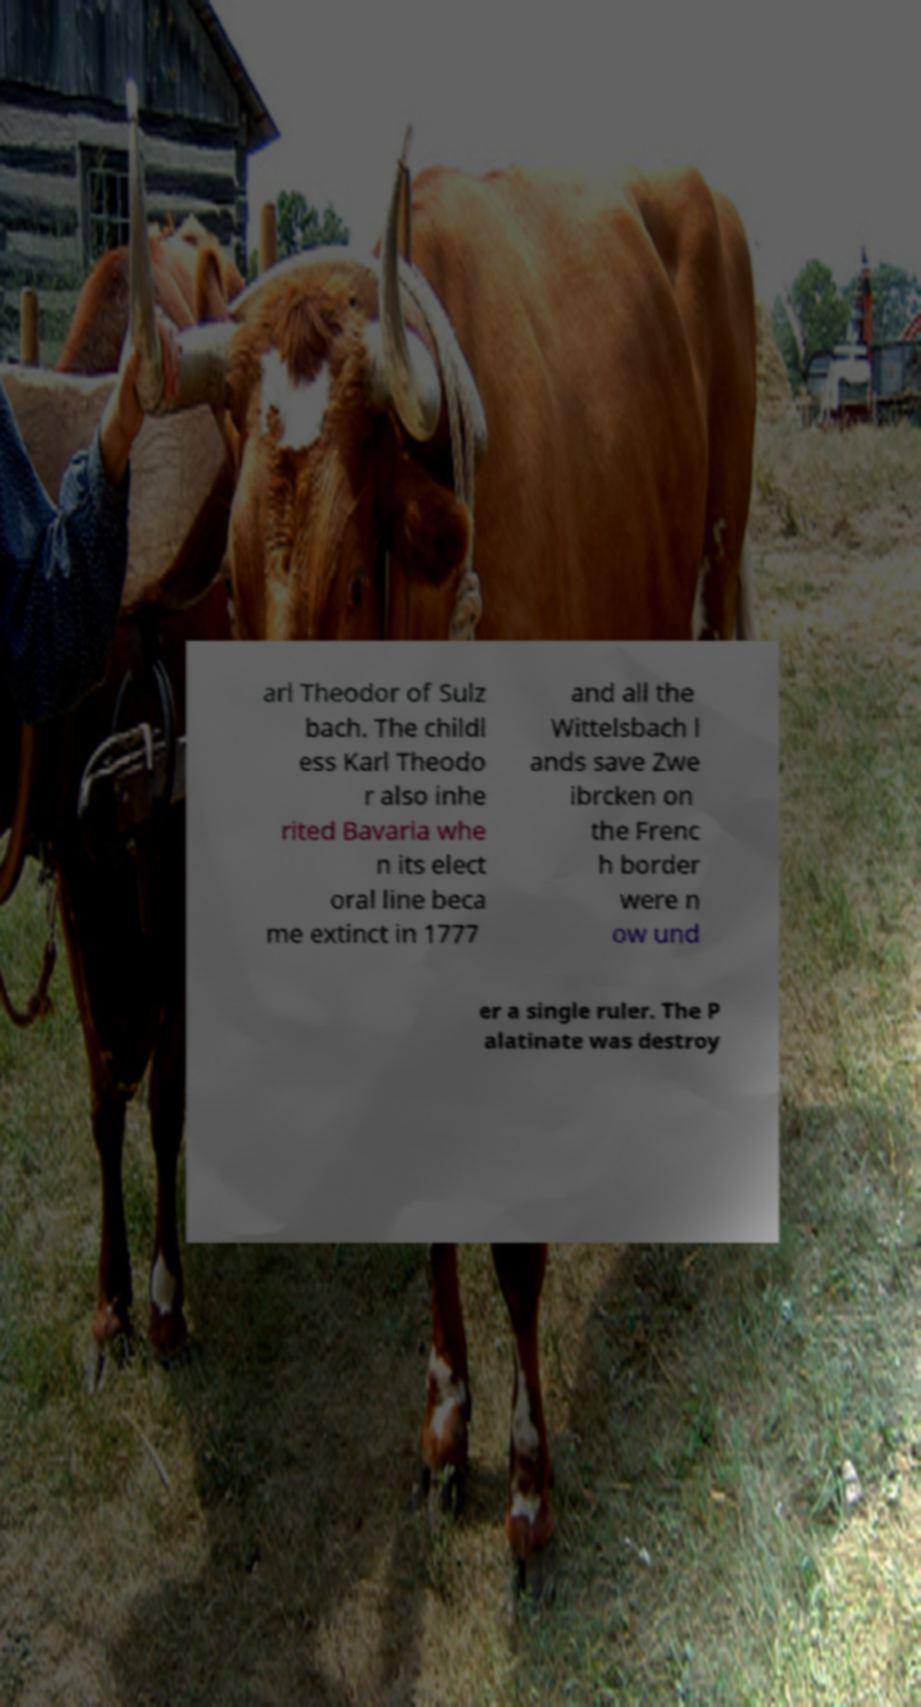Can you read and provide the text displayed in the image?This photo seems to have some interesting text. Can you extract and type it out for me? arl Theodor of Sulz bach. The childl ess Karl Theodo r also inhe rited Bavaria whe n its elect oral line beca me extinct in 1777 and all the Wittelsbach l ands save Zwe ibrcken on the Frenc h border were n ow und er a single ruler. The P alatinate was destroy 